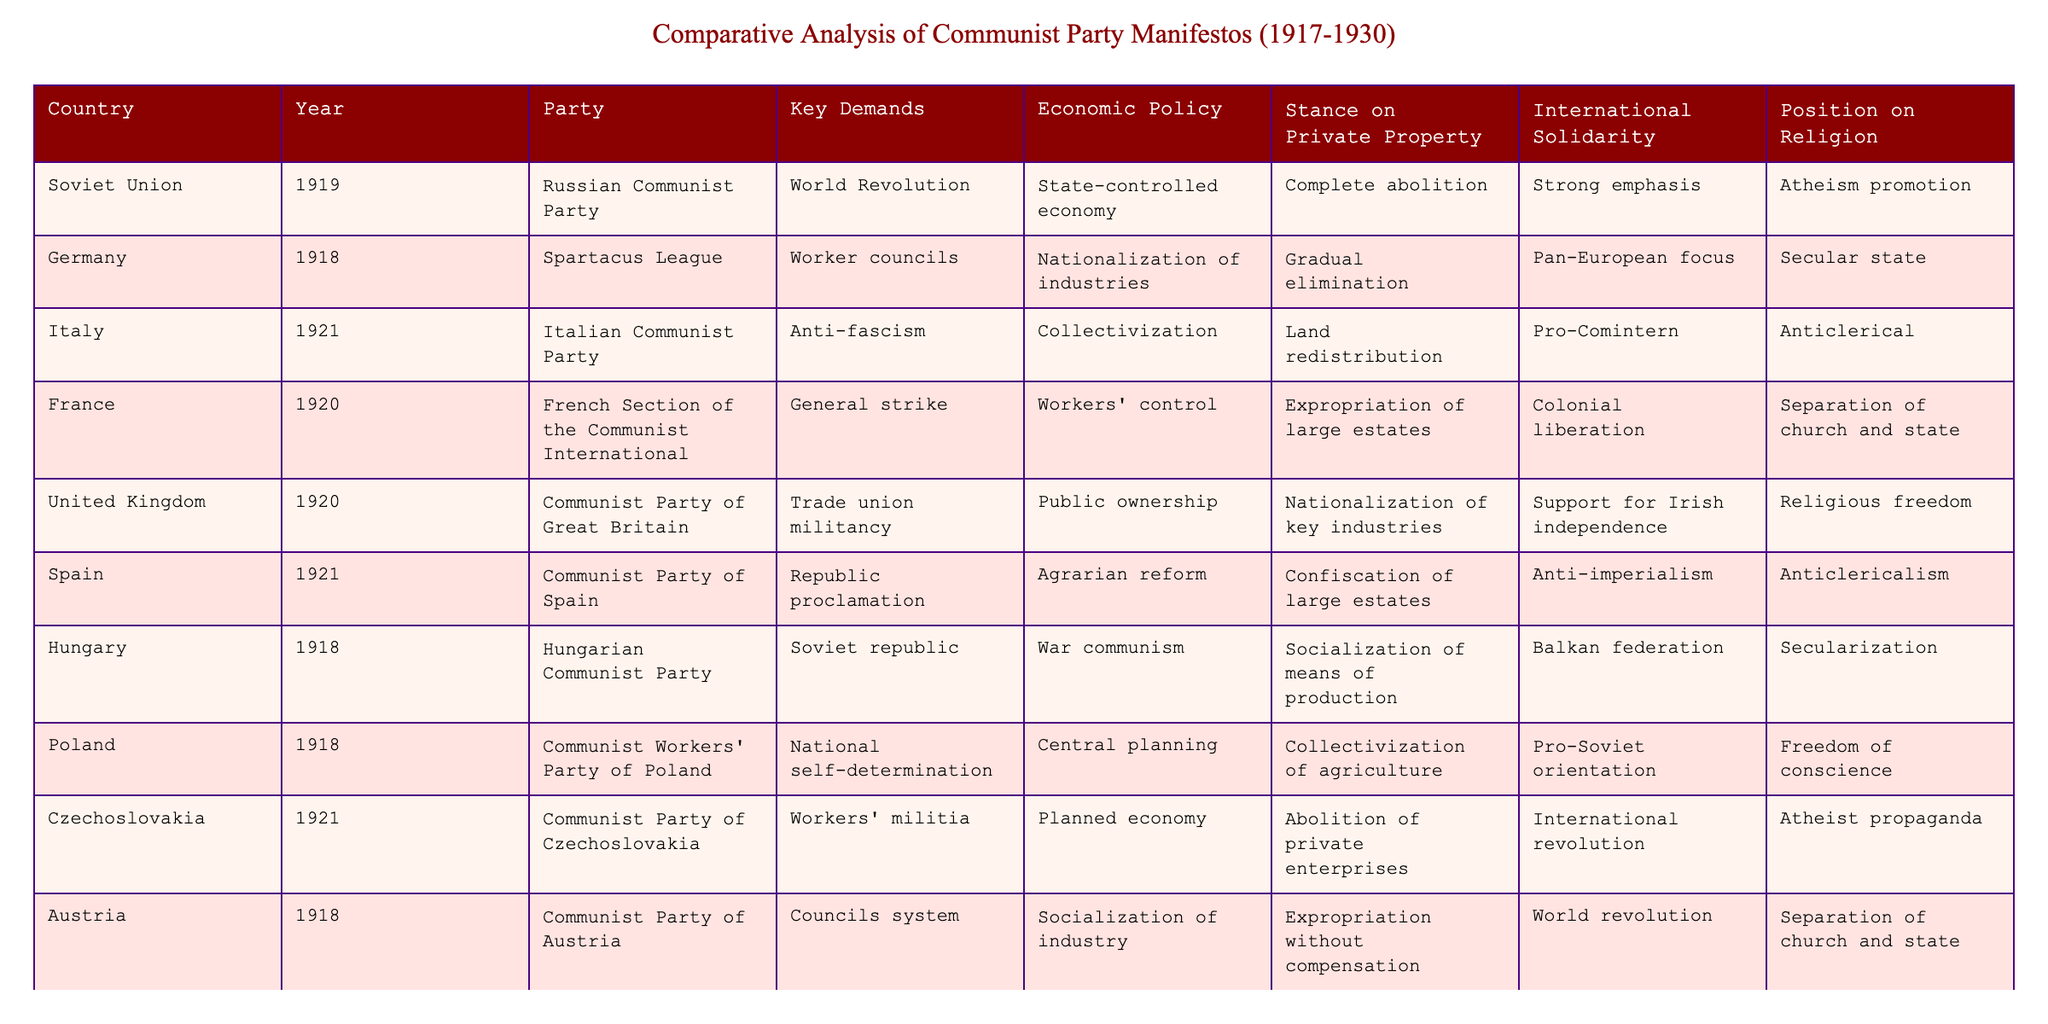What are the key demands of the German communist party? In the table, under the Germany row, the key demands of the Spartacus League are listed as "Worker councils."
Answer: Worker councils Which country has a communist party that supports Irish independence? Referring to the United Kingdom row in the table, the Communist Party of Great Britain's stance includes "Support for Irish independence."
Answer: United Kingdom Does the Italian Communist Party advocate for the complete abolition of private property? In the table, the Italian Communist Party's stance on private property is "Land redistribution," which means they do not advocate for complete abolition.
Answer: No What is the stance on religion taken by the Hungarian Communist Party? Looking at the Hungary row, the stance on religion is "Secularization."
Answer: Secularization Which two countries have a strong emphasis on international solidarity? In the Soviet Union and Czechoslovakia rows, both emphasize "Strong emphasis" and "International revolution" toward international solidarity.
Answer: Soviet Union and Czechoslovakia How many communist parties expressed opposition to religion? In the table, the parties that express opposition to religion are the Soviet Union, Czechoslovakia (Atheist propaganda), French Section (Separation of church and state), and Italy (Anticlerical). That accounts for four parties.
Answer: Four What differentiates the economic policy of the Communist Party of Spain from that of the Communist Party of Great Britain? The Communist Party of Spain advocates for "Agrarian reform" while the Communist Party of Great Britain supports "Public ownership," showcasing a difference in focus on agricultural versus industrial policy.
Answer: Different focuses on agriculture and industry Which countries promoted the idea of world revolution in their manifestos? The Soviet Union and Austria both mentioned "World Revolution" in their manifestos, indicating a shared global revolutionary perspective.
Answer: Soviet Union and Austria What is the common stance on private property among all the communist parties listed? By examining the data, it is clear that while some parties completely abolish it, others suggest nationalization or specific reforms, showing a diverse range of approaches to private property.
Answer: Diverse approaches Which country’s Communist Party was established first according to the table? The Communist Party mentioned for the Soviet Union in 1919 is the earliest party listed in the table, established after the Russian Revolution.
Answer: Soviet Union 